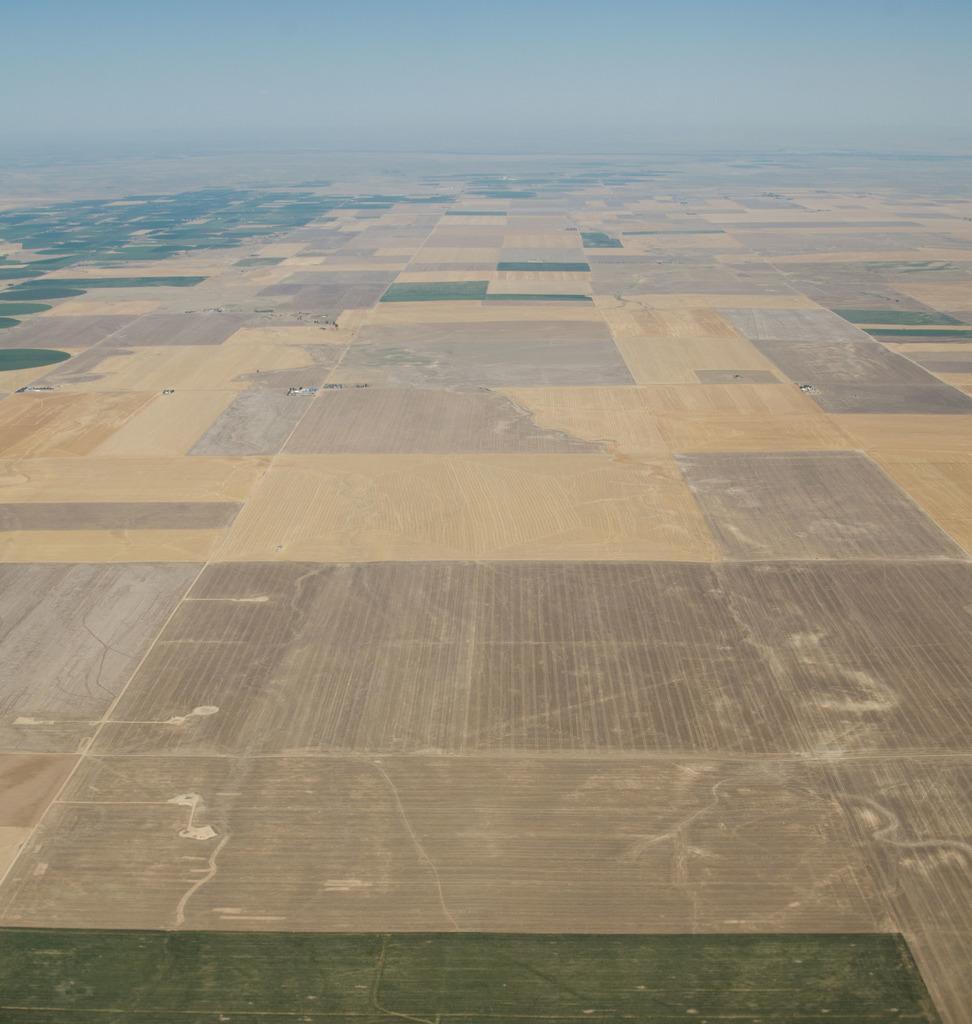Can you describe this image briefly? This picture shows the aerial photography. At the top there is the sky. There is some grass on the surface. 